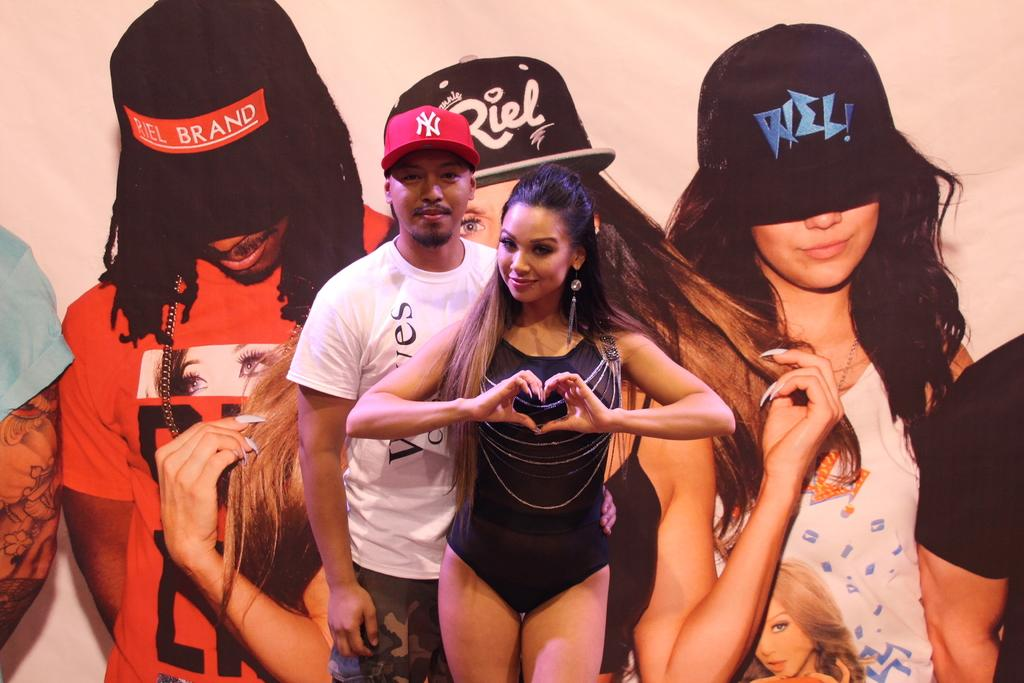<image>
Relay a brief, clear account of the picture shown. a man next to a lady with an ad behind it that says brand 